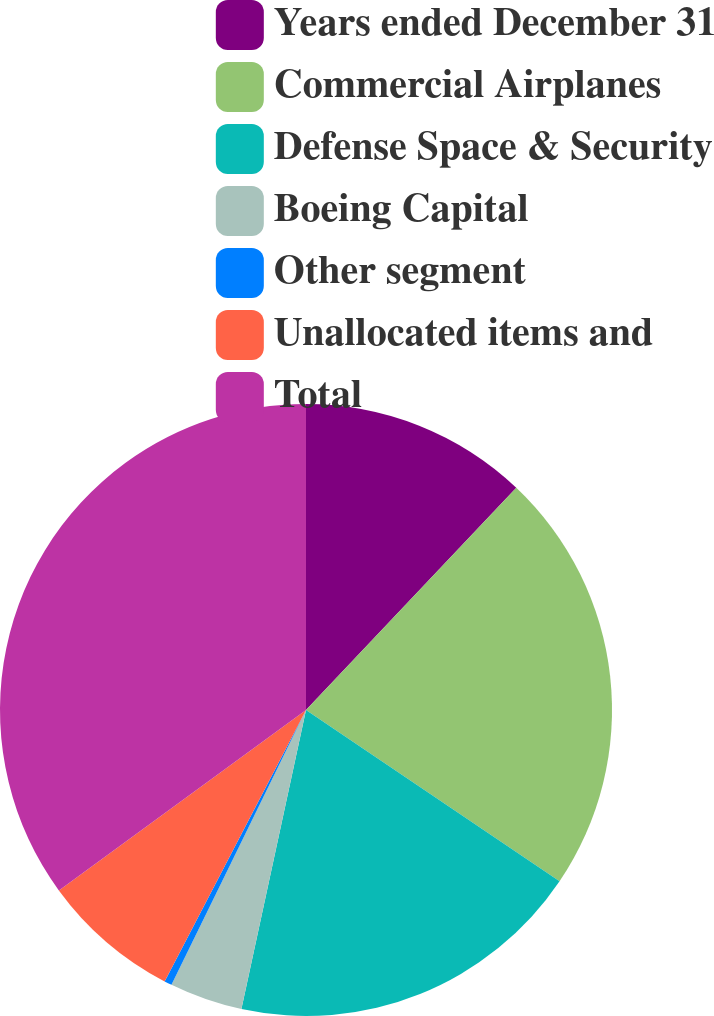<chart> <loc_0><loc_0><loc_500><loc_500><pie_chart><fcel>Years ended December 31<fcel>Commercial Airplanes<fcel>Defense Space & Security<fcel>Boeing Capital<fcel>Other segment<fcel>Unallocated items and<fcel>Total<nl><fcel>12.06%<fcel>22.4%<fcel>18.93%<fcel>3.86%<fcel>0.4%<fcel>7.32%<fcel>35.04%<nl></chart> 